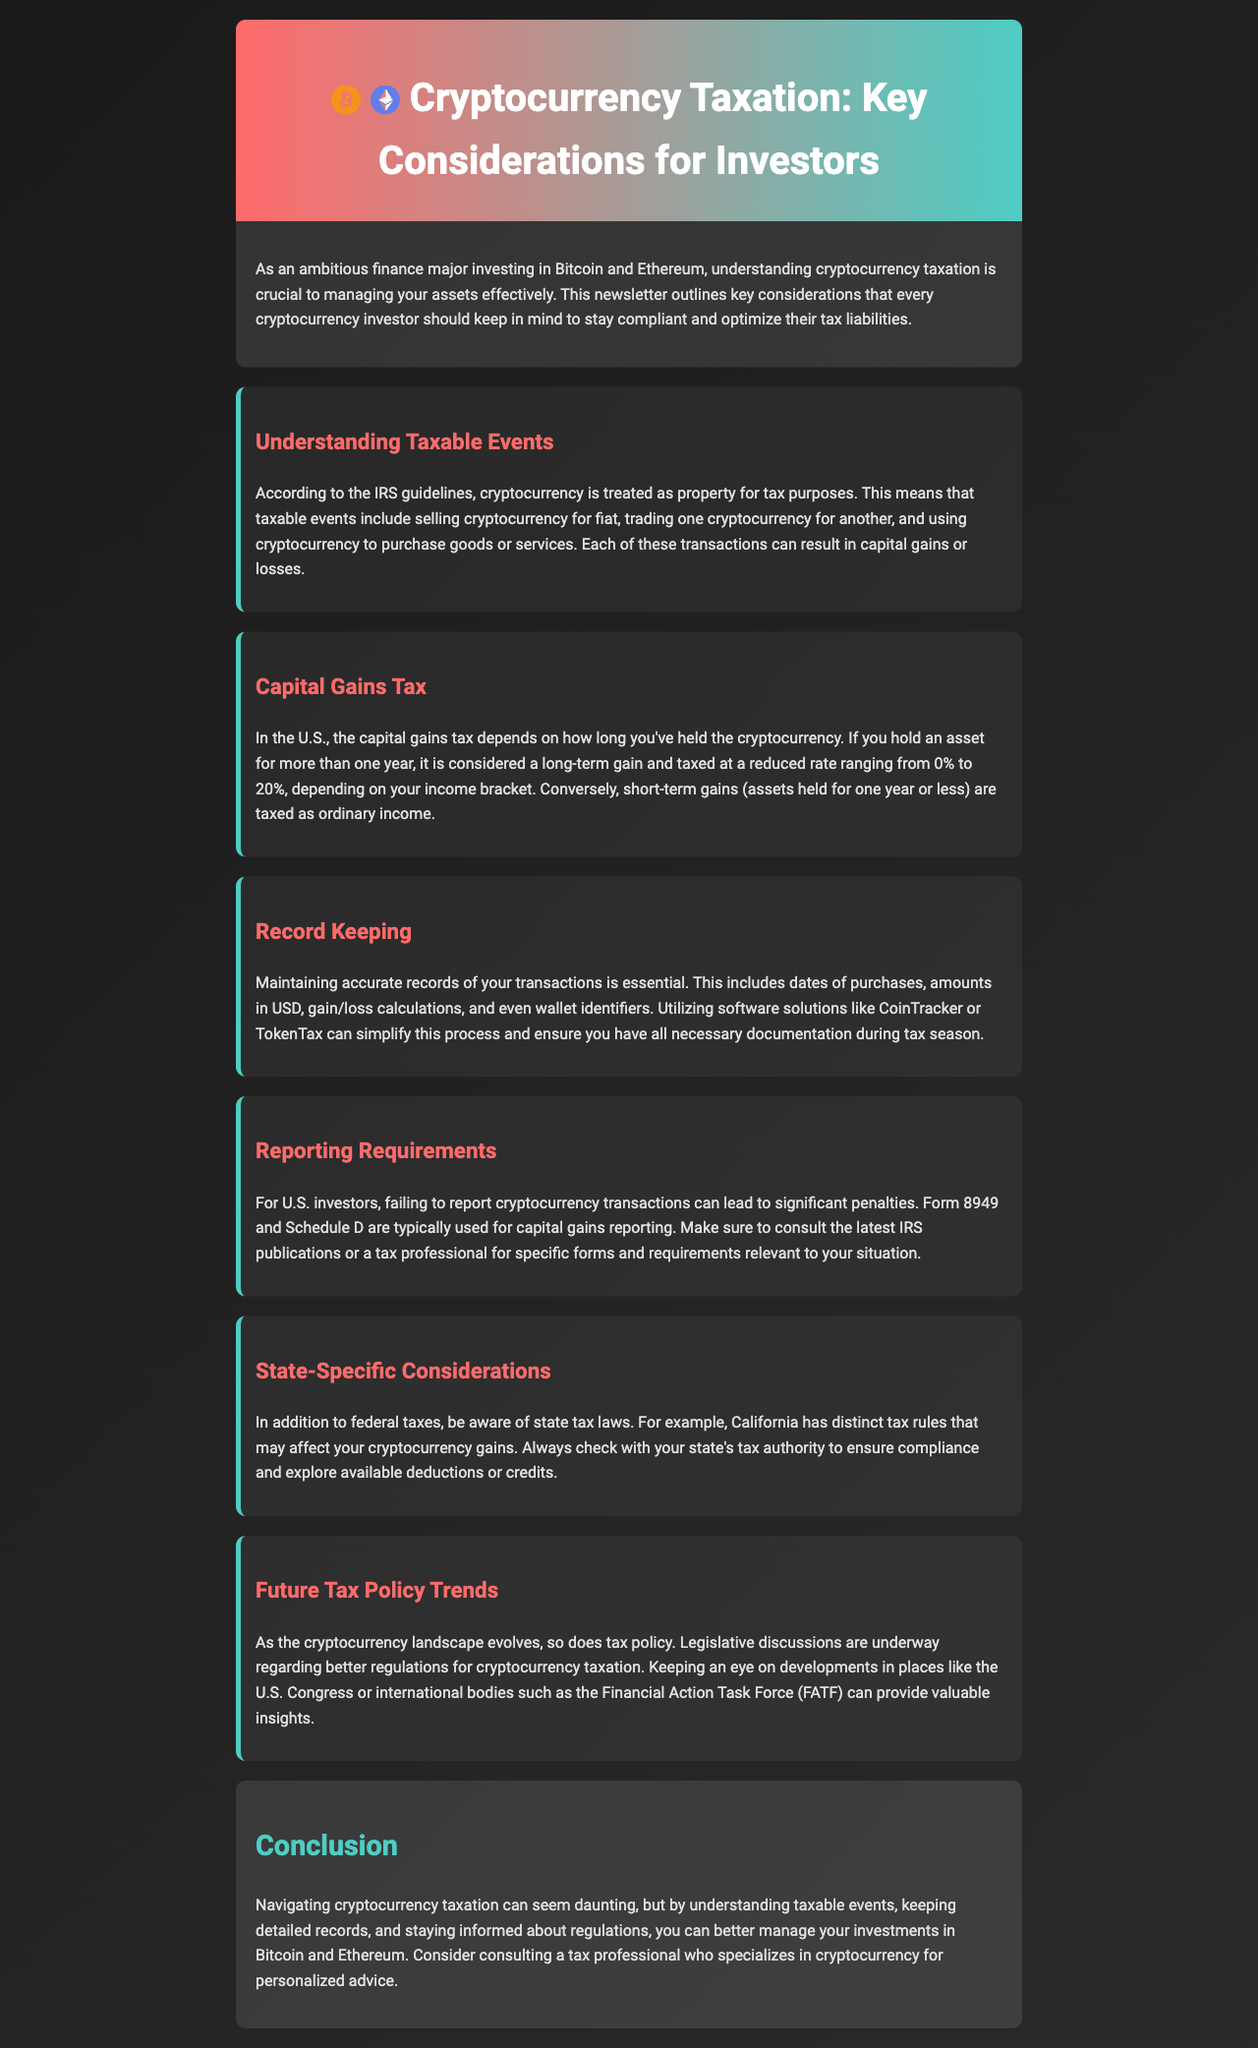What is cryptocurrency treated as for tax purposes? The document states that cryptocurrency is treated as property for tax purposes according to IRS guidelines.
Answer: property What is the capital gains tax rate for long-term holdings? The newsletter mentions that long-term gains are taxed at a reduced rate ranging from 0% to 20%.
Answer: 0% to 20% Which forms are used for capital gains reporting for U.S. investors? According to the document, Form 8949 and Schedule D are typically used for reporting.
Answer: Form 8949 and Schedule D What must investors maintain for their transactions? The document emphasizes maintaining accurate records of various details related to transactions.
Answer: accurate records What software can simplify record-keeping? The newsletter suggests utilizing software solutions like CoinTracker or TokenTax for this purpose.
Answer: CoinTracker or TokenTax What is a significant consequence of failing to report cryptocurrency transactions? The document warns that failing to report transactions can lead to significant penalties.
Answer: significant penalties What specific tax laws should investors be aware of in California? The newsletter indicates that California has distinct tax rules affecting cryptocurrency gains.
Answer: distinct tax rules What is a future consideration mentioned regarding cryptocurrency? The newsletter discusses that legislative discussions are underway regarding better regulations for cryptocurrency taxation.
Answer: better regulations 